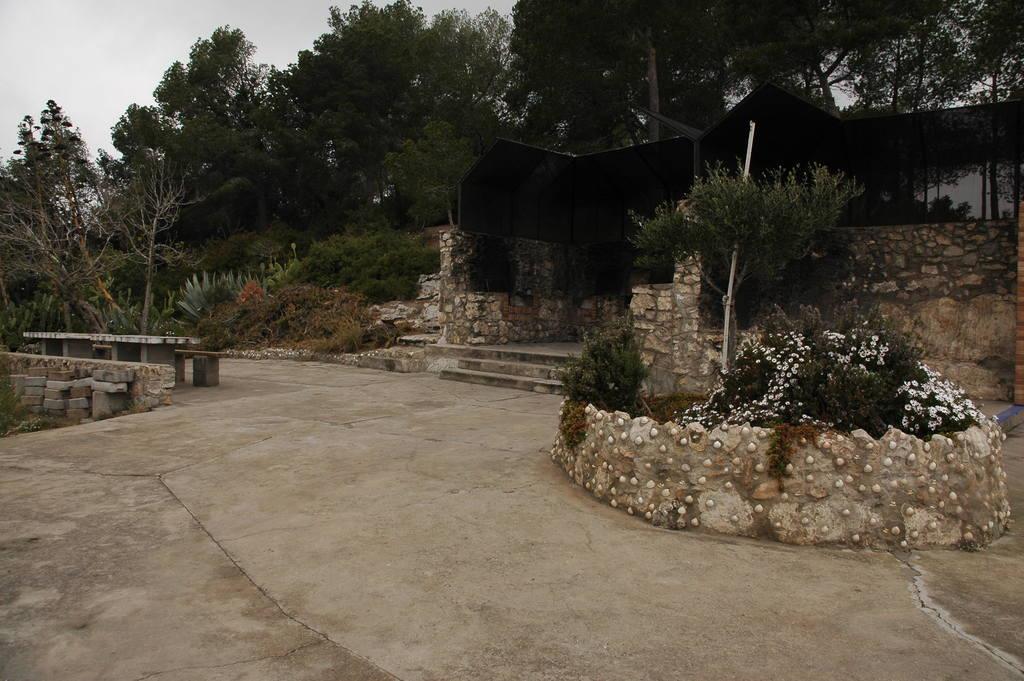In one or two sentences, can you explain what this image depicts? In this image, we can see the ground with some objects. We can see some plants, trees and benches. We can see the wall and the black colored shed. We can also see the sky. We can see some stones. 